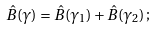Convert formula to latex. <formula><loc_0><loc_0><loc_500><loc_500>\hat { B } ( \gamma ) = \hat { B } ( \gamma _ { 1 } ) + \hat { B } ( \gamma _ { 2 } ) \, ;</formula> 